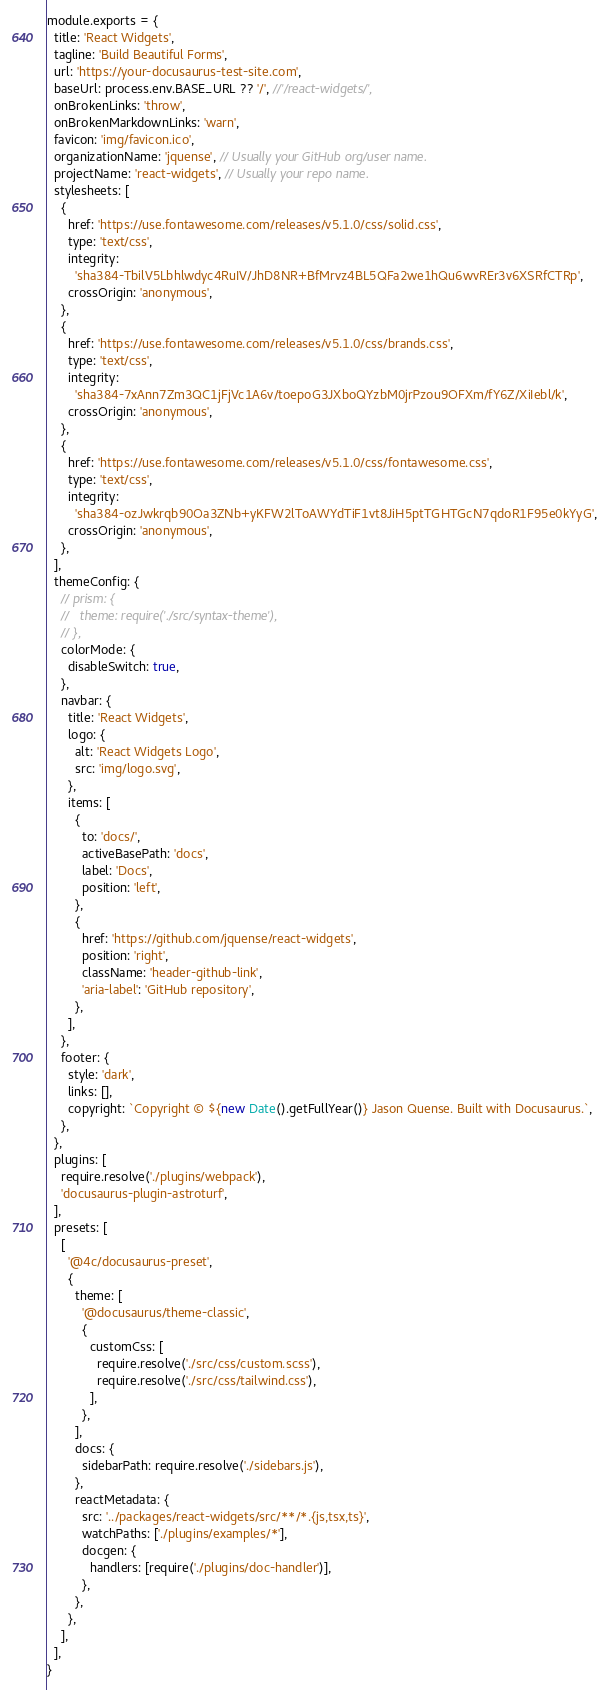Convert code to text. <code><loc_0><loc_0><loc_500><loc_500><_JavaScript_>module.exports = {
  title: 'React Widgets',
  tagline: 'Build Beautiful Forms',
  url: 'https://your-docusaurus-test-site.com',
  baseUrl: process.env.BASE_URL ?? '/', //'/react-widgets/',
  onBrokenLinks: 'throw',
  onBrokenMarkdownLinks: 'warn',
  favicon: 'img/favicon.ico',
  organizationName: 'jquense', // Usually your GitHub org/user name.
  projectName: 'react-widgets', // Usually your repo name.
  stylesheets: [
    {
      href: 'https://use.fontawesome.com/releases/v5.1.0/css/solid.css',
      type: 'text/css',
      integrity:
        'sha384-TbilV5Lbhlwdyc4RuIV/JhD8NR+BfMrvz4BL5QFa2we1hQu6wvREr3v6XSRfCTRp',
      crossOrigin: 'anonymous',
    },
    {
      href: 'https://use.fontawesome.com/releases/v5.1.0/css/brands.css',
      type: 'text/css',
      integrity:
        'sha384-7xAnn7Zm3QC1jFjVc1A6v/toepoG3JXboQYzbM0jrPzou9OFXm/fY6Z/XiIebl/k',
      crossOrigin: 'anonymous',
    },
    {
      href: 'https://use.fontawesome.com/releases/v5.1.0/css/fontawesome.css',
      type: 'text/css',
      integrity:
        'sha384-ozJwkrqb90Oa3ZNb+yKFW2lToAWYdTiF1vt8JiH5ptTGHTGcN7qdoR1F95e0kYyG',
      crossOrigin: 'anonymous',
    },
  ],
  themeConfig: {
    // prism: {
    //   theme: require('./src/syntax-theme'),
    // },
    colorMode: {
      disableSwitch: true,
    },
    navbar: {
      title: 'React Widgets',
      logo: {
        alt: 'React Widgets Logo',
        src: 'img/logo.svg',
      },
      items: [
        {
          to: 'docs/',
          activeBasePath: 'docs',
          label: 'Docs',
          position: 'left',
        },
        {
          href: 'https://github.com/jquense/react-widgets',
          position: 'right',
          className: 'header-github-link',
          'aria-label': 'GitHub repository',
        },
      ],
    },
    footer: {
      style: 'dark',
      links: [],
      copyright: `Copyright © ${new Date().getFullYear()} Jason Quense. Built with Docusaurus.`,
    },
  },
  plugins: [
    require.resolve('./plugins/webpack'),
    'docusaurus-plugin-astroturf',
  ],
  presets: [
    [
      '@4c/docusaurus-preset',
      {
        theme: [
          '@docusaurus/theme-classic',
          {
            customCss: [
              require.resolve('./src/css/custom.scss'),
              require.resolve('./src/css/tailwind.css'),
            ],
          },
        ],
        docs: {
          sidebarPath: require.resolve('./sidebars.js'),
        },
        reactMetadata: {
          src: '../packages/react-widgets/src/**/*.{js,tsx,ts}',
          watchPaths: ['./plugins/examples/*'],
          docgen: {
            handlers: [require('./plugins/doc-handler')],
          },
        },
      },
    ],
  ],
}
</code> 